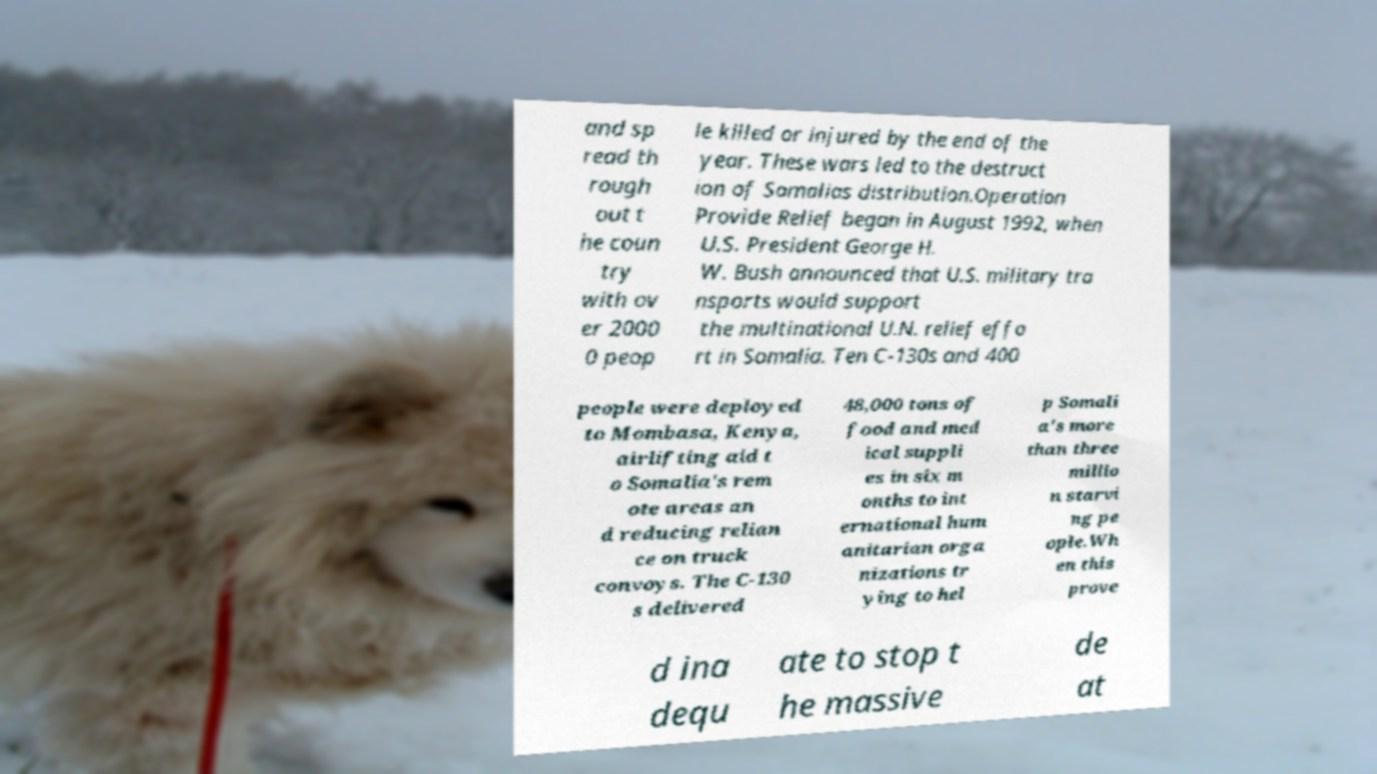Could you extract and type out the text from this image? and sp read th rough out t he coun try with ov er 2000 0 peop le killed or injured by the end of the year. These wars led to the destruct ion of Somalias distribution.Operation Provide Relief began in August 1992, when U.S. President George H. W. Bush announced that U.S. military tra nsports would support the multinational U.N. relief effo rt in Somalia. Ten C-130s and 400 people were deployed to Mombasa, Kenya, airlifting aid t o Somalia's rem ote areas an d reducing relian ce on truck convoys. The C-130 s delivered 48,000 tons of food and med ical suppli es in six m onths to int ernational hum anitarian orga nizations tr ying to hel p Somali a's more than three millio n starvi ng pe ople.Wh en this prove d ina dequ ate to stop t he massive de at 